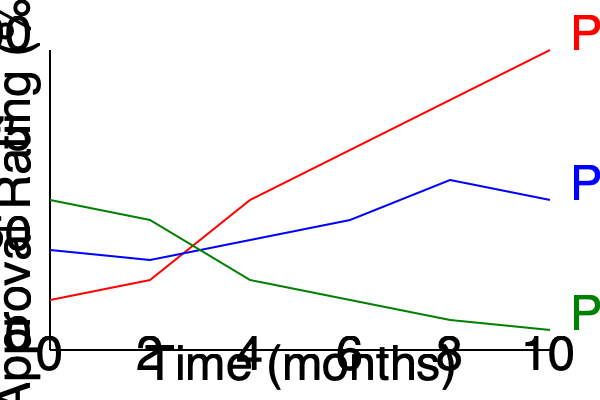Based on the line graph showing approval ratings of three student policies over time, which policy experienced the most significant decline in approval rating from the beginning to the end of the 10-month period? To determine which policy experienced the most significant decline in approval rating, we need to compare the starting and ending points for each policy:

1. Policy A (red line):
   Start: ~25% approval
   End: ~85% approval
   Change: +60% (increase)

2. Policy B (blue line):
   Start: ~50% approval
   End: ~60% approval
   Change: +10% (increase)

3. Policy C (green line):
   Start: ~60% approval
   End: ~35% approval
   Change: -25% (decrease)

Policy A and B both show increases in approval rating over time, while Policy C is the only one that shows a decline. Therefore, Policy C experienced the most significant decline in approval rating from the beginning to the end of the 10-month period.
Answer: Policy C 